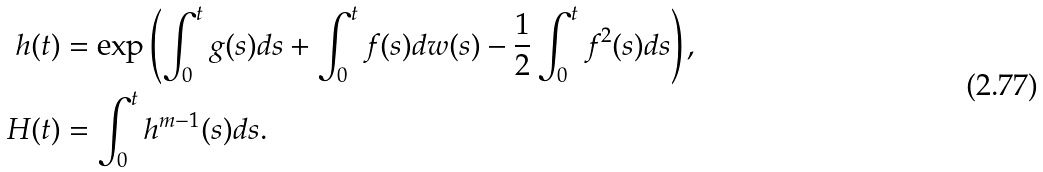Convert formula to latex. <formula><loc_0><loc_0><loc_500><loc_500>h ( t ) & = \exp \left ( \int _ { 0 } ^ { t } g ( s ) d s + \int _ { 0 } ^ { t } f ( s ) d w ( s ) - \frac { 1 } { 2 } \int _ { 0 } ^ { t } f ^ { 2 } ( s ) d s \right ) , \\ \ H ( t ) & = \int _ { 0 } ^ { t } h ^ { m - 1 } ( s ) d s .</formula> 